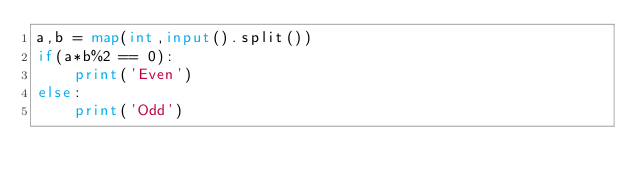<code> <loc_0><loc_0><loc_500><loc_500><_Python_>a,b = map(int,input().split())
if(a*b%2 == 0):
    print('Even')
else:
    print('Odd')</code> 